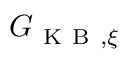<formula> <loc_0><loc_0><loc_500><loc_500>G _ { K B , \xi }</formula> 